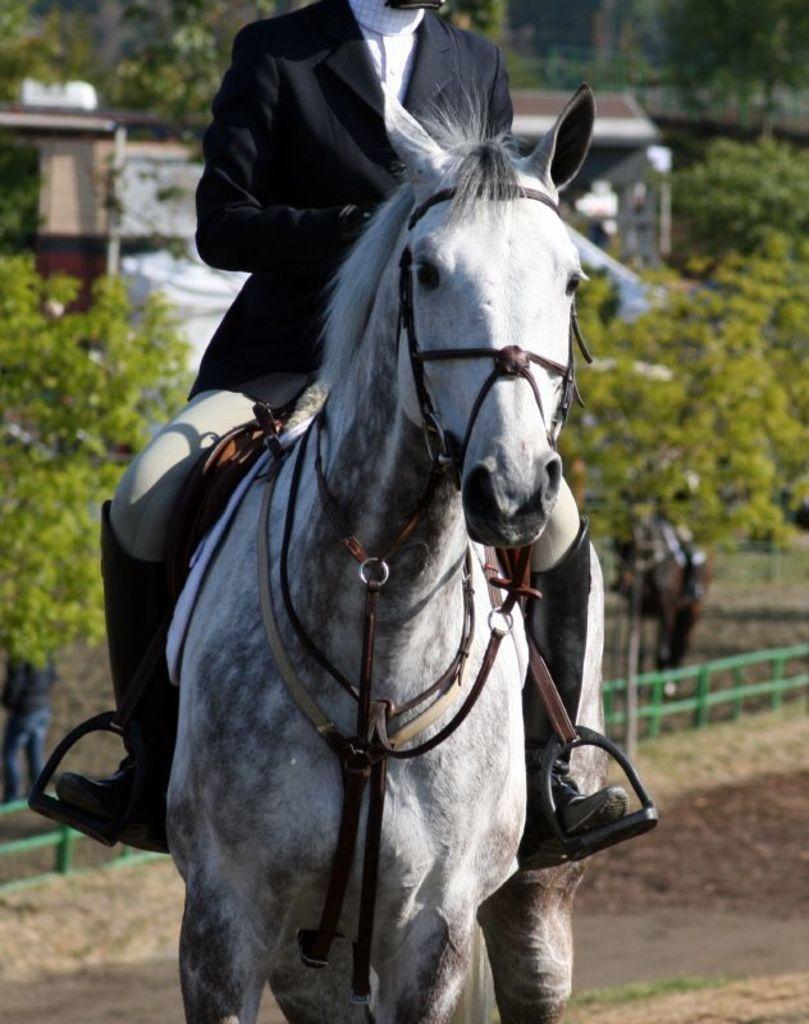Can you describe this image briefly? In this picture there is a person at the center of the image, who is riding the horse, there are some trees around the area of the image, it seems to be a road side. 